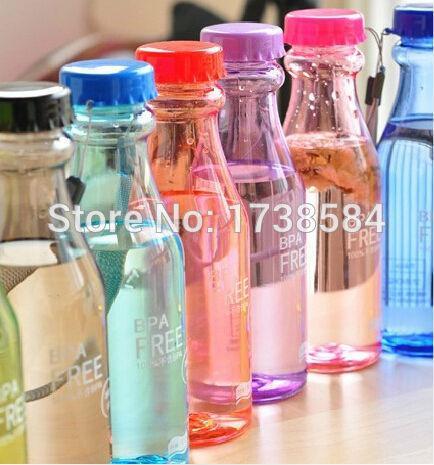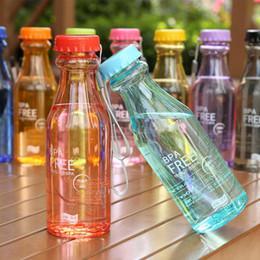The first image is the image on the left, the second image is the image on the right. Given the left and right images, does the statement "One of the bottles is tilted and being propped up by another bottle." hold true? Answer yes or no. Yes. The first image is the image on the left, the second image is the image on the right. For the images displayed, is the sentence "The right image shows one bottle leaning on an upright bottle, in front of a row of similar bottles shown in different colors." factually correct? Answer yes or no. Yes. 